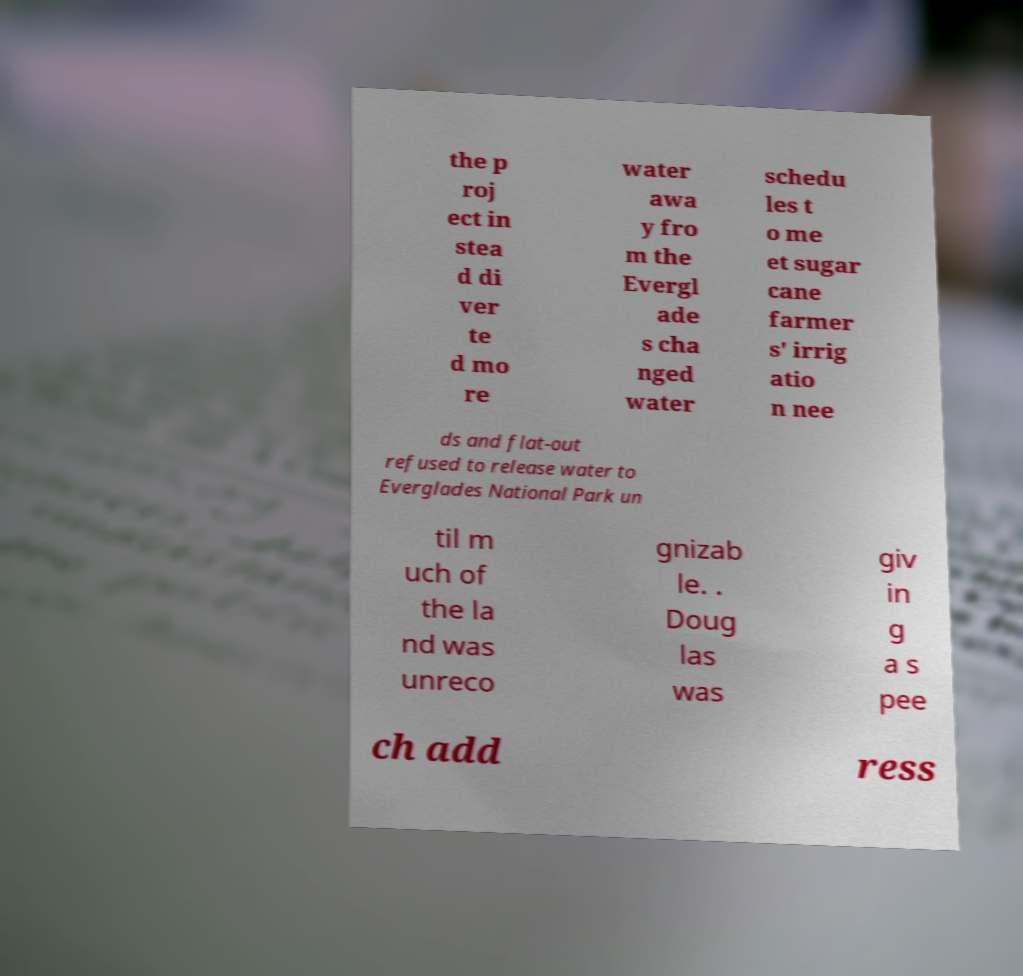What messages or text are displayed in this image? I need them in a readable, typed format. the p roj ect in stea d di ver te d mo re water awa y fro m the Evergl ade s cha nged water schedu les t o me et sugar cane farmer s' irrig atio n nee ds and flat-out refused to release water to Everglades National Park un til m uch of the la nd was unreco gnizab le. . Doug las was giv in g a s pee ch add ress 